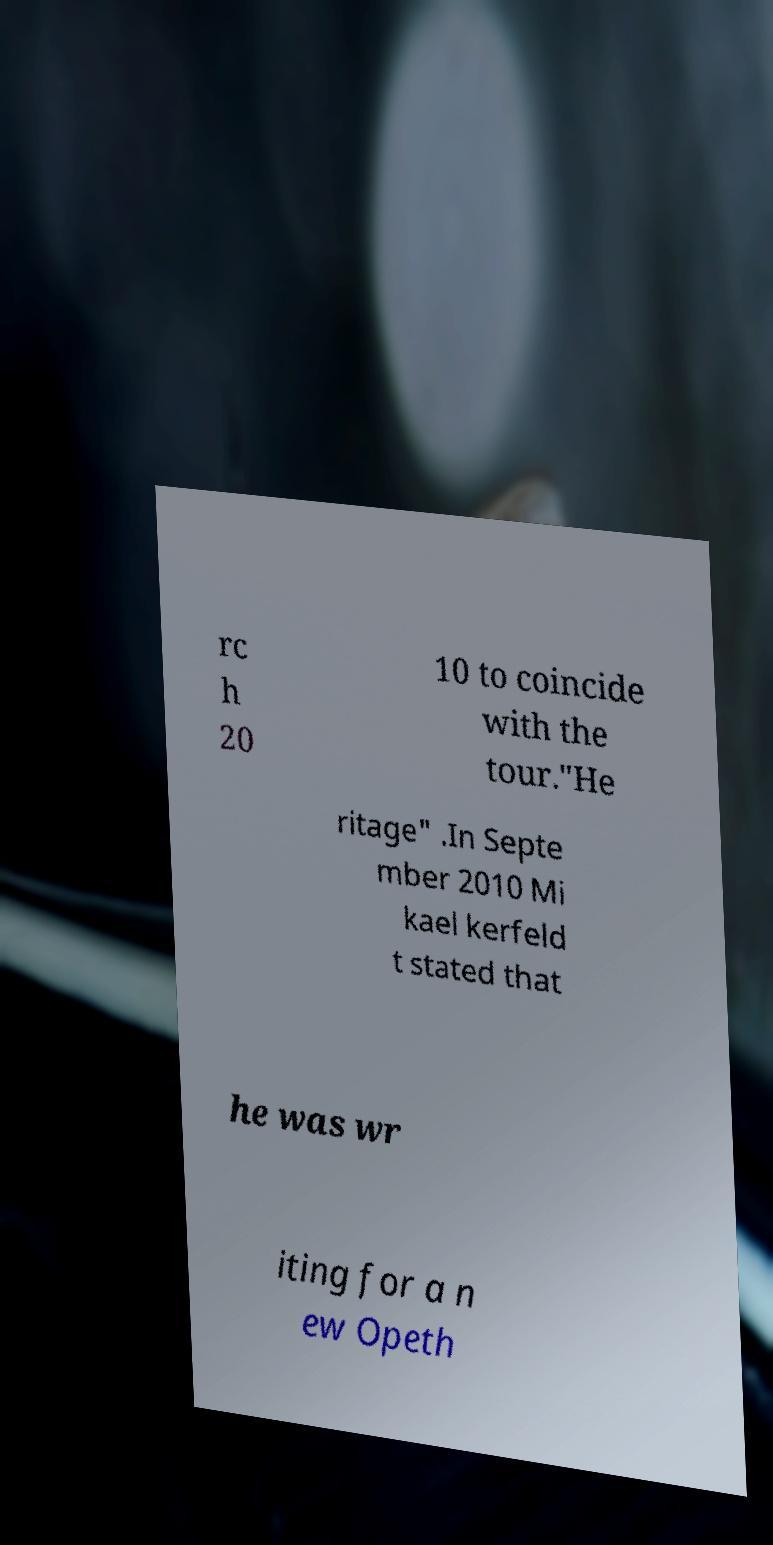Could you extract and type out the text from this image? rc h 20 10 to coincide with the tour."He ritage" .In Septe mber 2010 Mi kael kerfeld t stated that he was wr iting for a n ew Opeth 